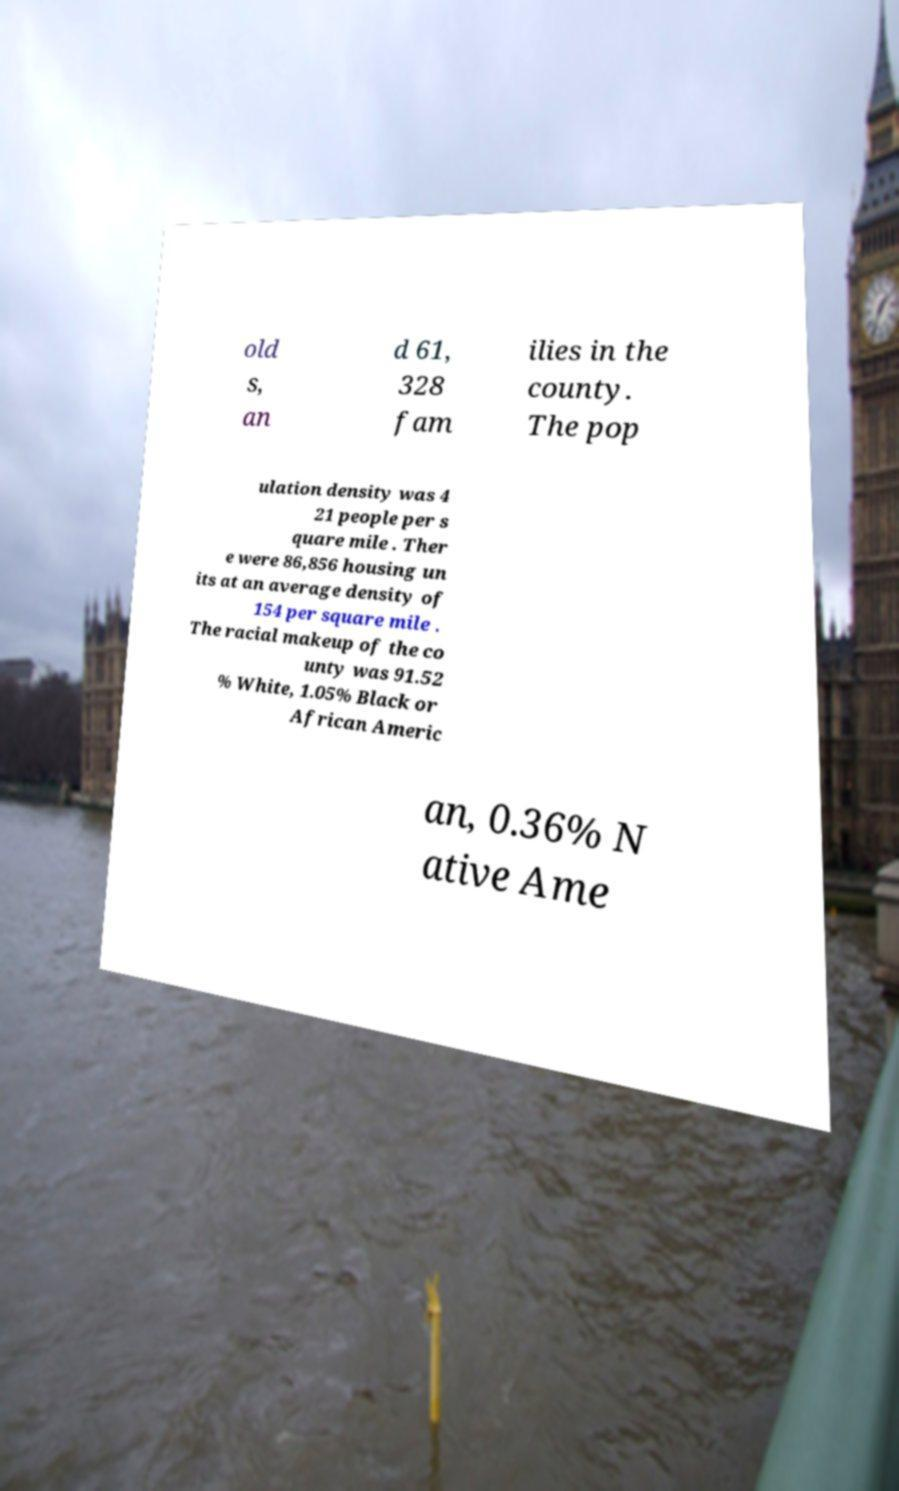Could you assist in decoding the text presented in this image and type it out clearly? old s, an d 61, 328 fam ilies in the county. The pop ulation density was 4 21 people per s quare mile . Ther e were 86,856 housing un its at an average density of 154 per square mile . The racial makeup of the co unty was 91.52 % White, 1.05% Black or African Americ an, 0.36% N ative Ame 